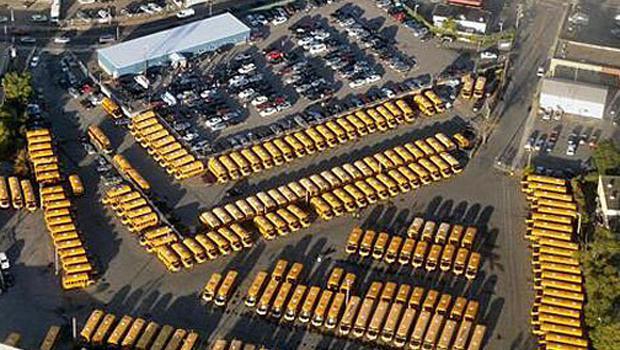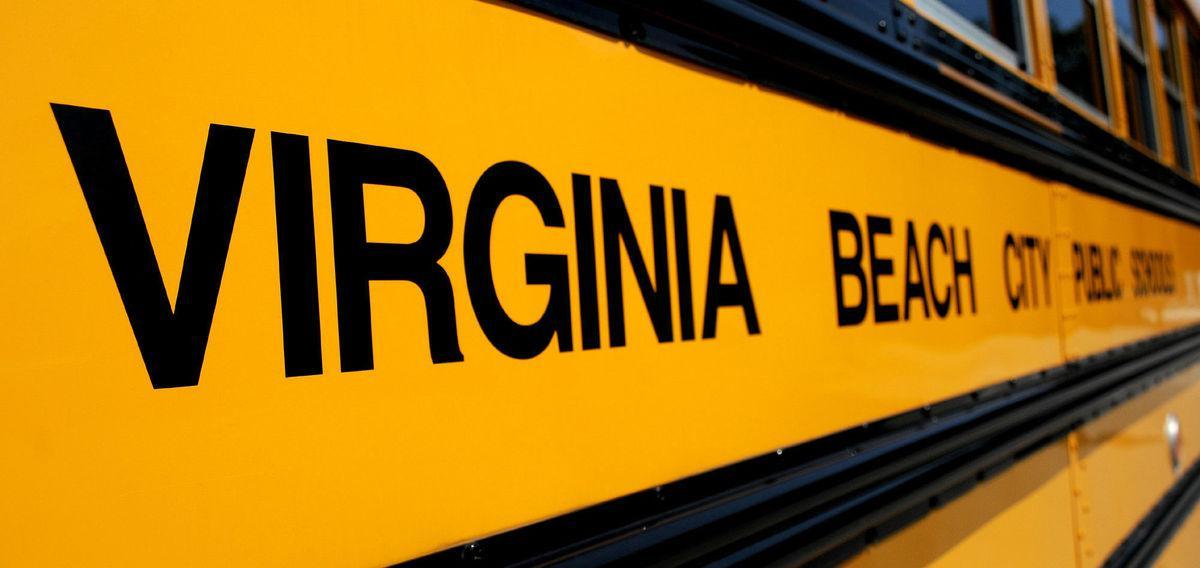The first image is the image on the left, the second image is the image on the right. Analyze the images presented: Is the assertion "Words are written across the side of a school bus in the image on the right." valid? Answer yes or no. Yes. The first image is the image on the left, the second image is the image on the right. Analyze the images presented: Is the assertion "The right image contains an aerial view of a school bus parking lot." valid? Answer yes or no. No. 